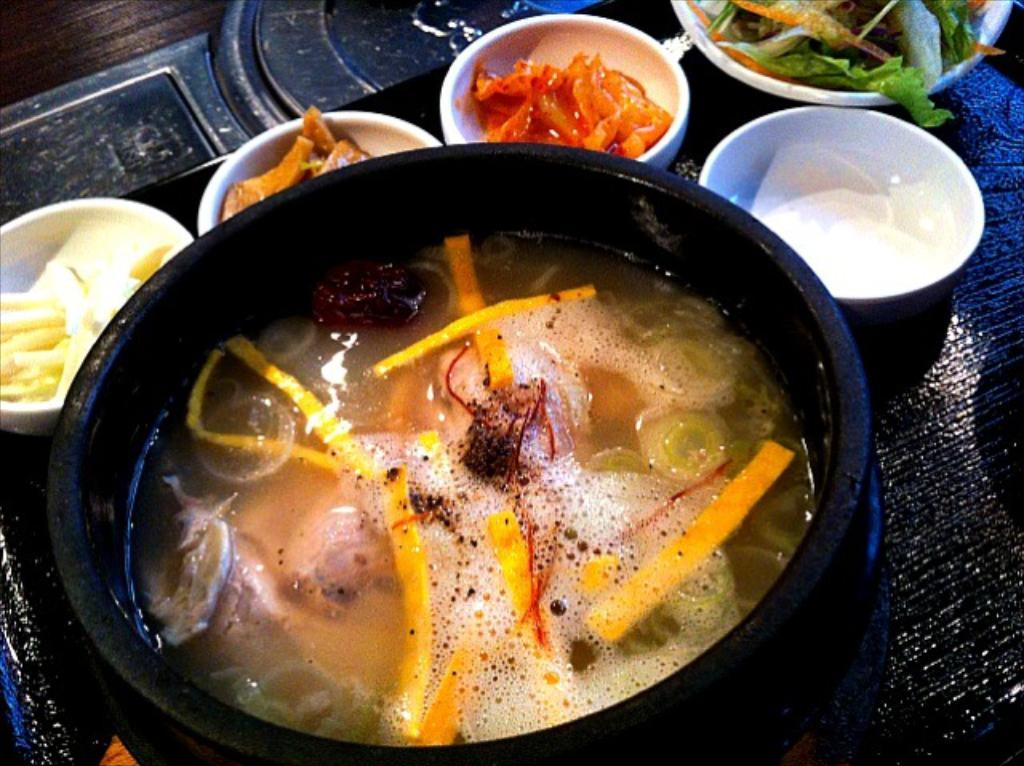What type of kitchenware is present in the image? There is a pan and bowls in the image. What are the bowls containing? The bowls contain different food items. Where are the pan and bowls located? The pan and bowls are placed on a table. How many ducks are swimming in the bowls in the image? There are no ducks present in the image; the bowls contain food items. What type of clouds can be seen in the image? There are no clouds visible in the image, as it is focused on kitchenware items placed on a table. 